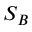<formula> <loc_0><loc_0><loc_500><loc_500>S _ { B }</formula> 